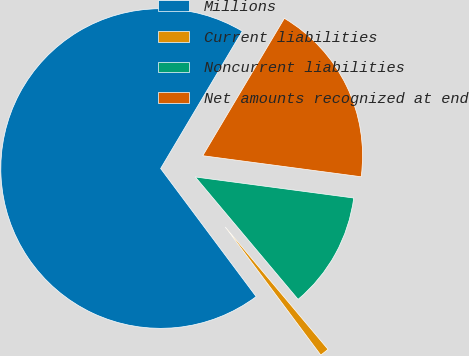Convert chart. <chart><loc_0><loc_0><loc_500><loc_500><pie_chart><fcel>Millions<fcel>Current liabilities<fcel>Noncurrent liabilities<fcel>Net amounts recognized at end<nl><fcel>68.73%<fcel>0.92%<fcel>11.78%<fcel>18.57%<nl></chart> 